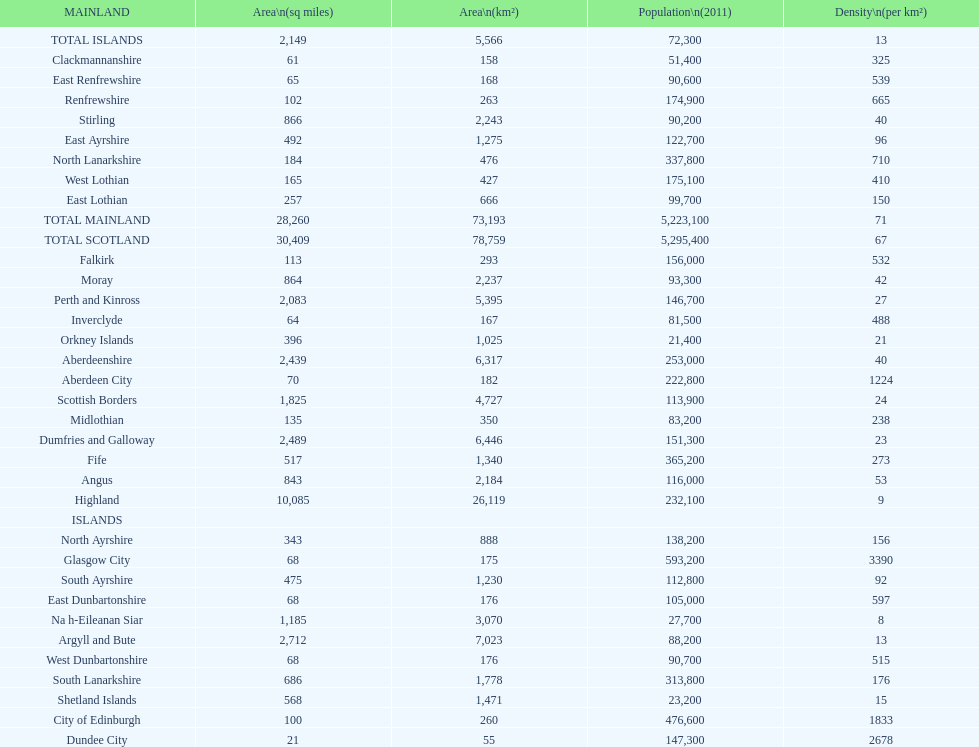Which mainland has the least population? Clackmannanshire. 